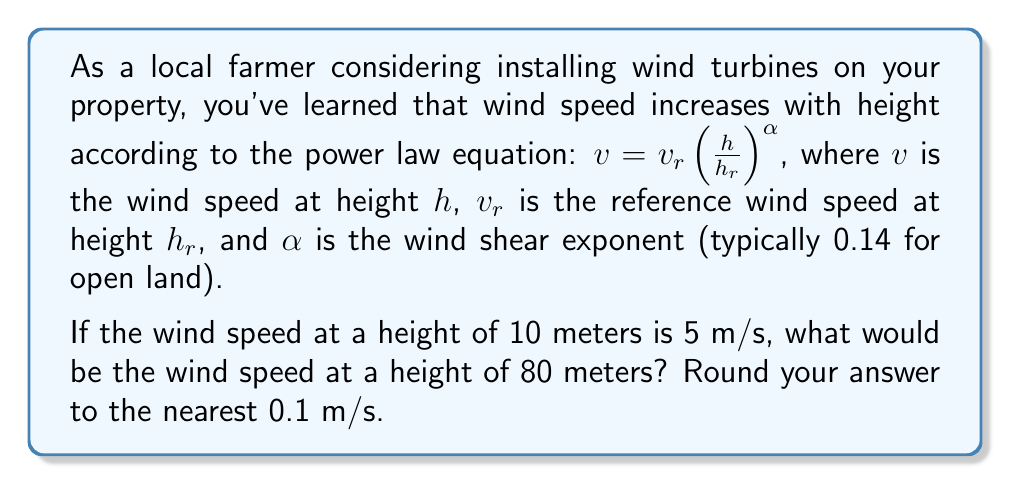Help me with this question. To solve this problem, we'll use the power law equation:

$v = v_r (\frac{h}{h_r})^α$

Given:
- $v_r = 5$ m/s (reference wind speed)
- $h_r = 10$ m (reference height)
- $h = 80$ m (height we're calculating for)
- $α = 0.14$ (wind shear exponent for open land)

Let's substitute these values into the equation:

$v = 5 (\frac{80}{10})^{0.14}$

Now, let's solve step by step:

1) First, calculate the fraction inside the parentheses:
   $\frac{80}{10} = 8$

2) Our equation now looks like:
   $v = 5 (8)^{0.14}$

3) Calculate $8^{0.14}$ using a calculator:
   $8^{0.14} ≈ 1.3095$

4) Multiply this by 5:
   $v = 5 * 1.3095 = 6.5475$ m/s

5) Rounding to the nearest 0.1 m/s:
   $v ≈ 6.5$ m/s
Answer: The wind speed at a height of 80 meters would be approximately 6.5 m/s. 